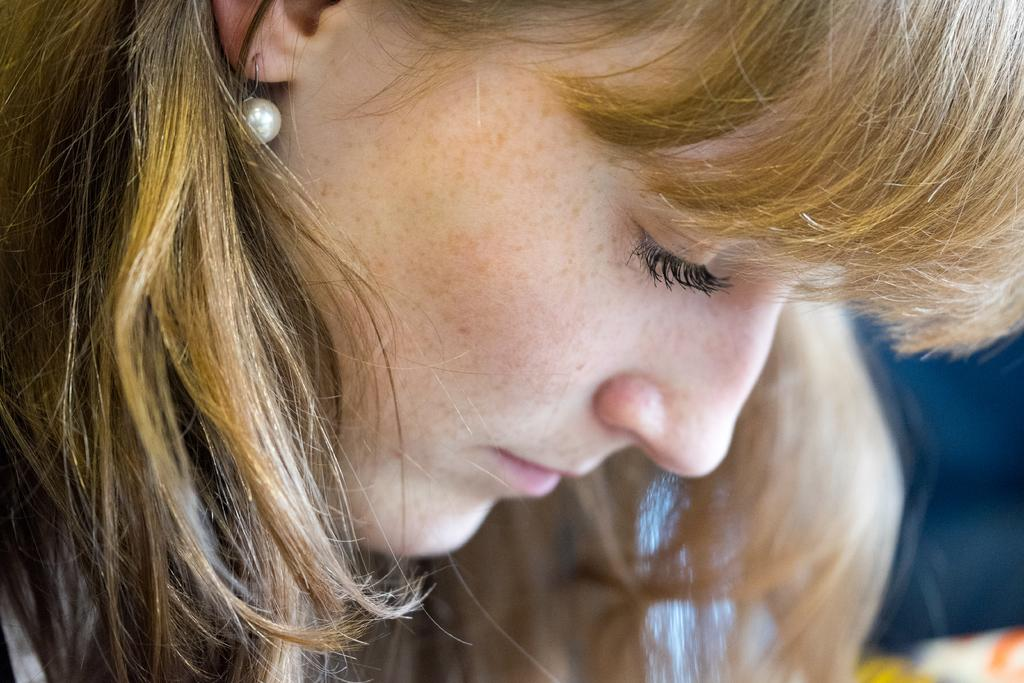Who is present in the image? There is a woman in the image. What is the woman doing in the image? The woman is looking downwards. What type of sheet is the woman using to make her selection of oatmeal in the image? There is no sheet or oatmeal present in the image; it only features a woman looking downwards. 